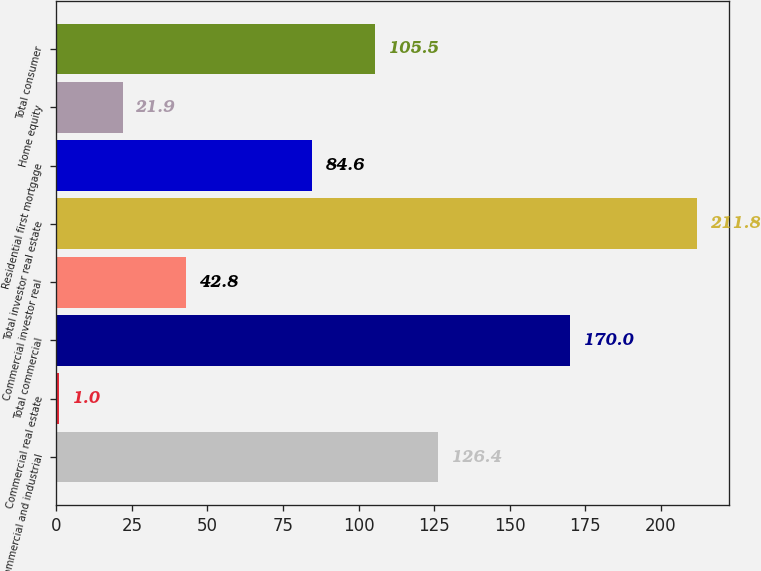Convert chart to OTSL. <chart><loc_0><loc_0><loc_500><loc_500><bar_chart><fcel>Commercial and industrial<fcel>Commercial real estate<fcel>Total commercial<fcel>Commercial investor real<fcel>Total investor real estate<fcel>Residential first mortgage<fcel>Home equity<fcel>Total consumer<nl><fcel>126.4<fcel>1<fcel>170<fcel>42.8<fcel>211.8<fcel>84.6<fcel>21.9<fcel>105.5<nl></chart> 